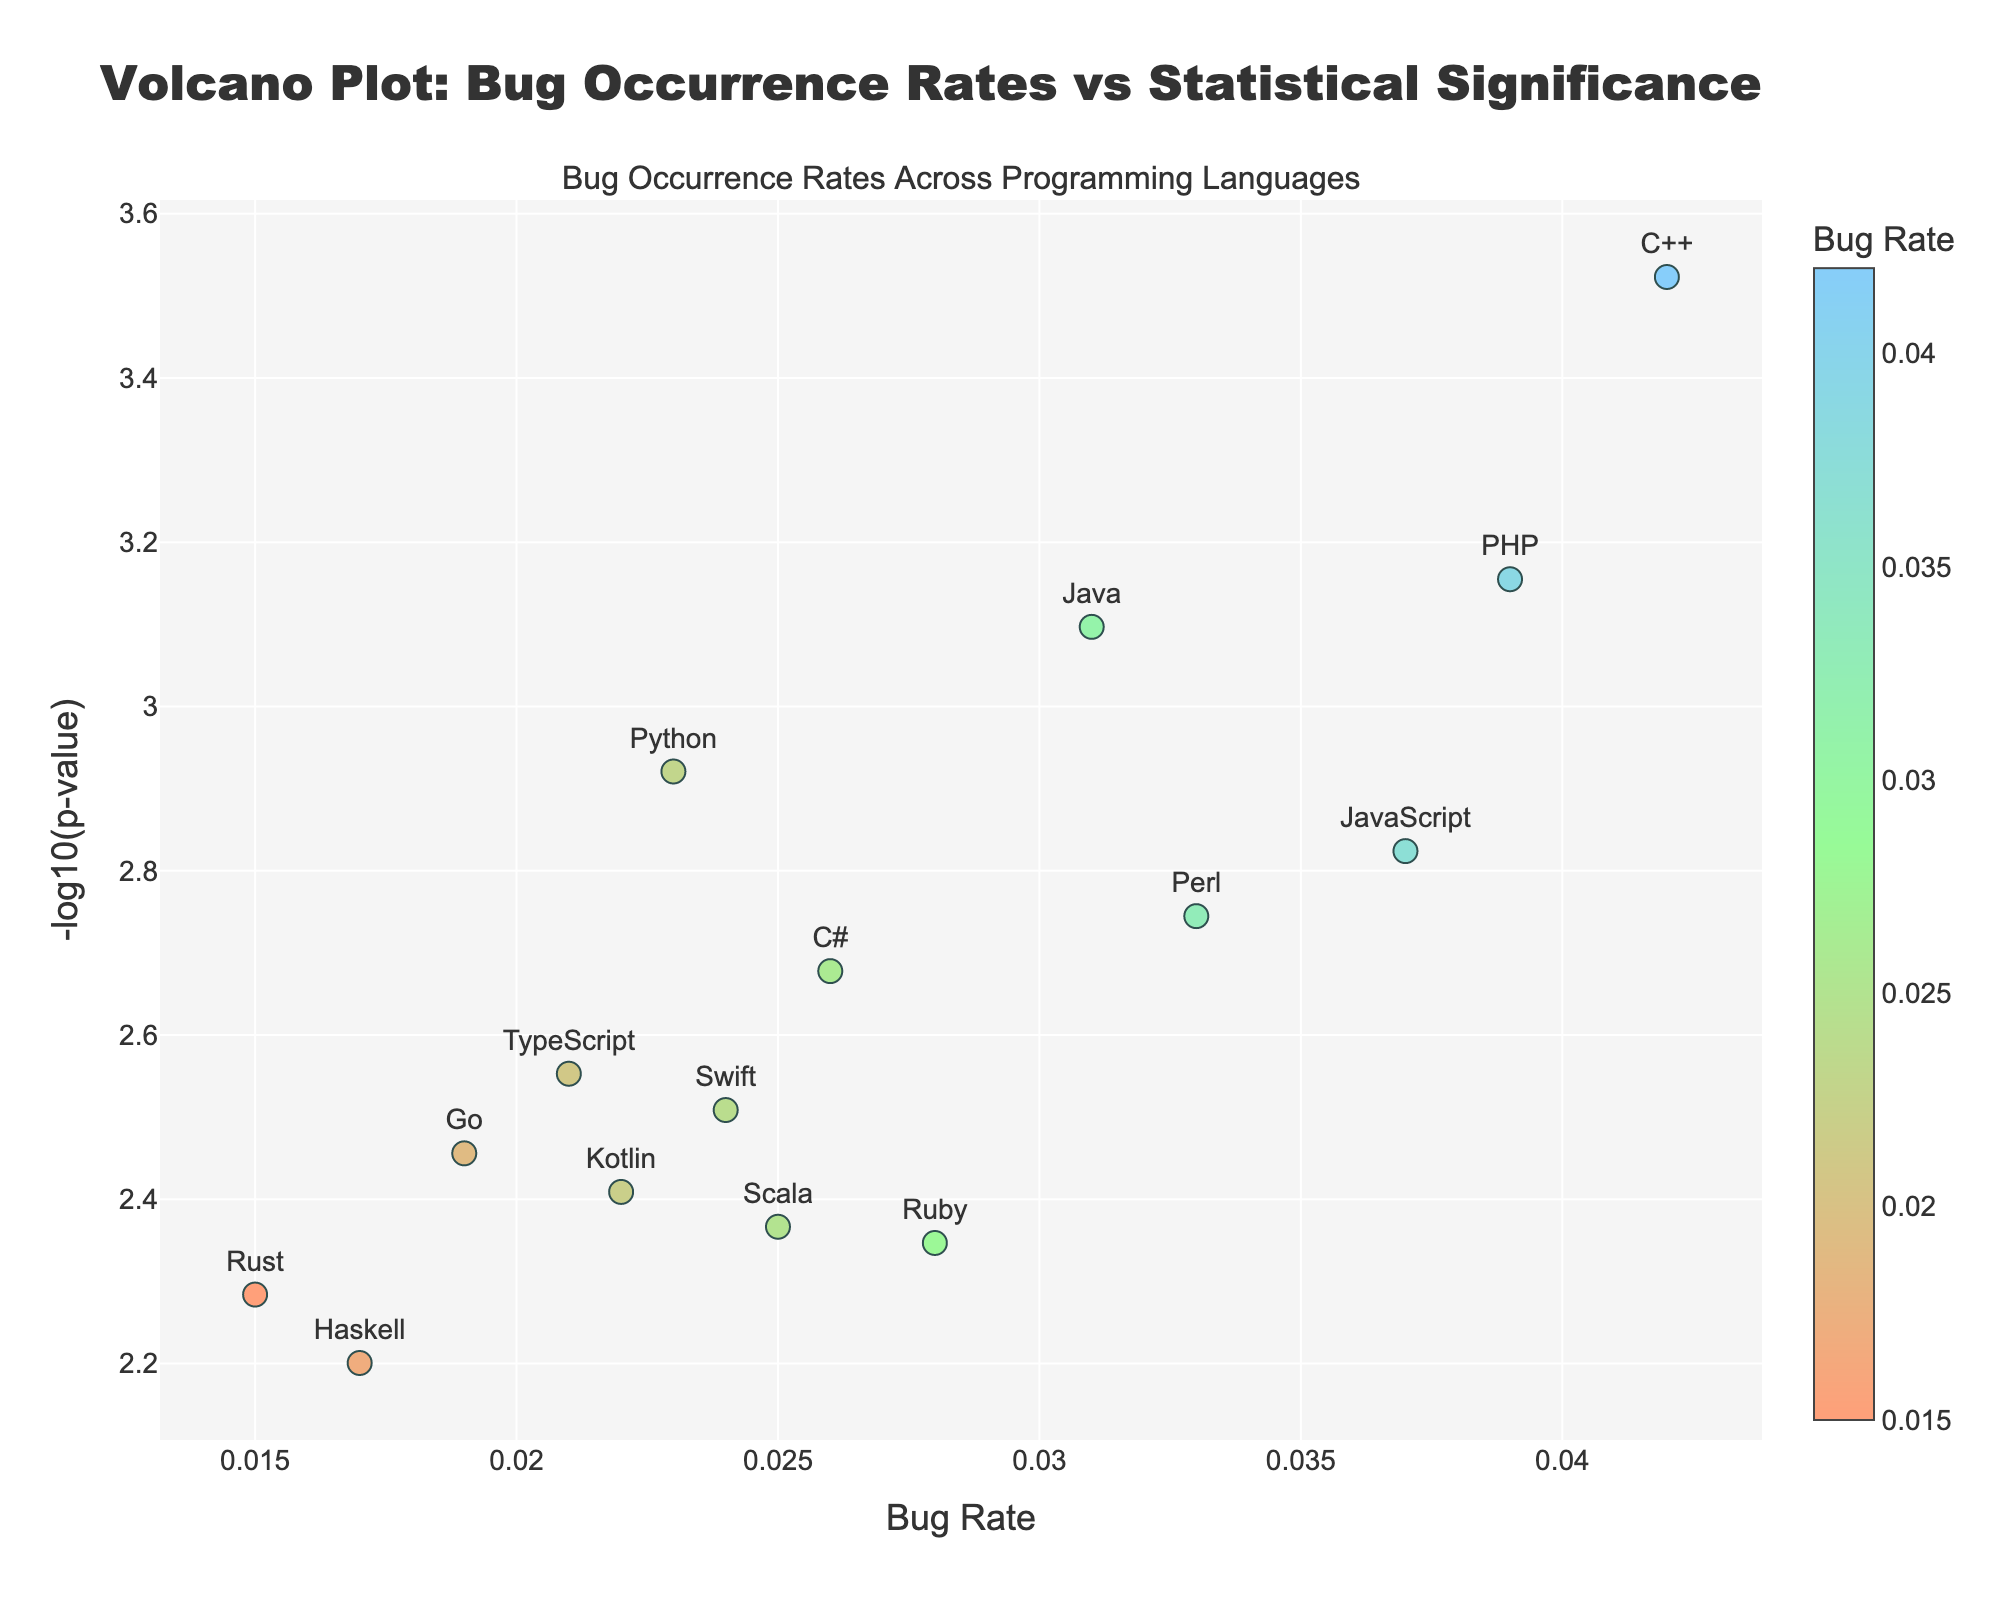What is the title of the plot? The title is located at the top of the plot. It provides a summary of what the plot is representing.
Answer: Volcano Plot: Bug Occurrence Rates vs Statistical Significance How many programming languages are represented in the plot? Each programming language is represented as a point in the plot. Count the number of labeled points in the plot.
Answer: 15 Which programming language has the highest bug rate? Identify the point that is farthest to the right on the x-axis (Bug Rate). The label at this point will be the programming language with the highest bug rate.
Answer: C++ What is the range of values for the y-axis? Observe the minimum and maximum values on the y-axis, which measures the -log10(p-value).
Answer: Approximately 2.5 to 5.5 Which language has the most statistically significant p-value? Identify the point that is highest on the y-axis since -log10(p-value) is higher for more statistically significant values.
Answer: C++ Compare the bug rates between Python and JavaScript. Which one is higher? Look at the x-axis values for Python and JavaScript. Compare these values.
Answer: JavaScript Which programming language has the lowest -log10(p-value) value? Identify the point that is lowest on the y-axis, indicating less statistical significance.
Answer: Haskell What is the bug rate and p-value for the Rust programming language? Find the point labeled Rust and read off the values from the x-axis (bug rate) and hover text (p-value).
Answer: Bug Rate: 0.015, p-value: 0.0052 Which two languages are closest in terms of bug rates? Look for points that are nearest to each other along the x-axis (Bug Rate).
Answer: Rust and Haskell What does a higher position on the y-axis represent in terms of p-value? A higher position on the y-axis corresponds to a lower p-value since we are plotting -log10(p-value).
Answer: Lower p-value 